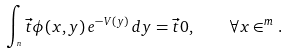<formula> <loc_0><loc_0><loc_500><loc_500>\int _ { \real ^ { n } } \vec { t } \phi ( x , y ) \, e ^ { - V ( y ) } \, d y = \vec { t } 0 , \quad \forall x \in \real ^ { m } .</formula> 